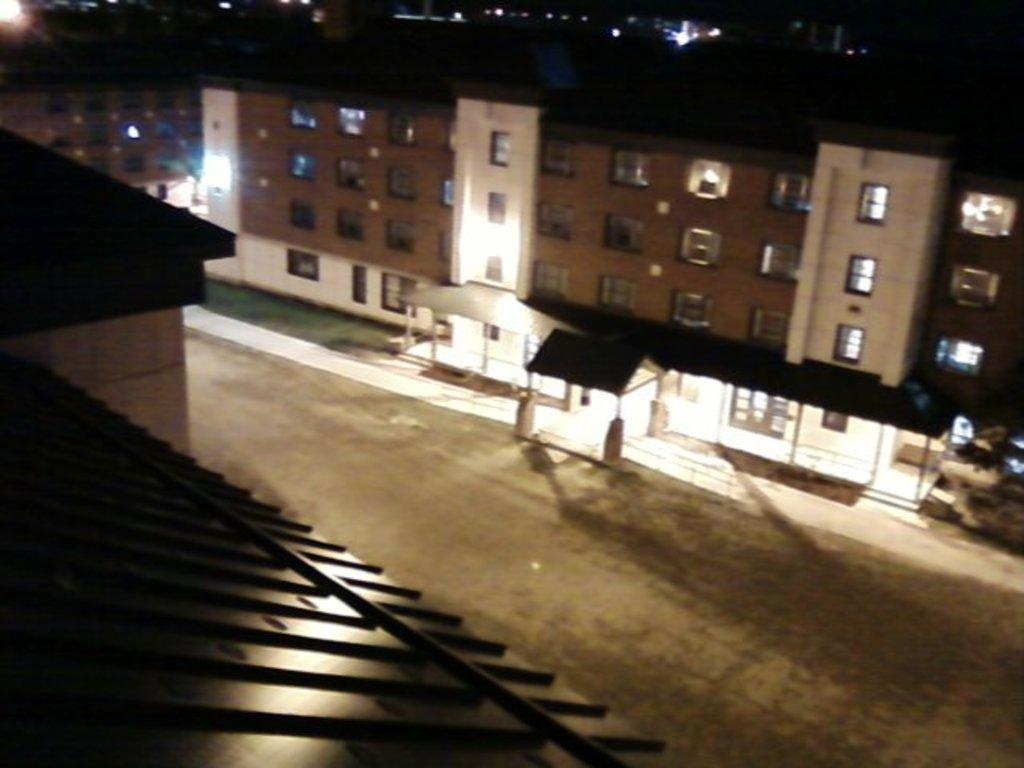What type of structures can be seen in the image? There are buildings in the image. What else is visible in the image besides the buildings? There are lights and a road in the image. How many pencils can be seen on the road in the image? There are no pencils present on the road in the image. What type of currency is being used in the image? There is no money visible in the image. 